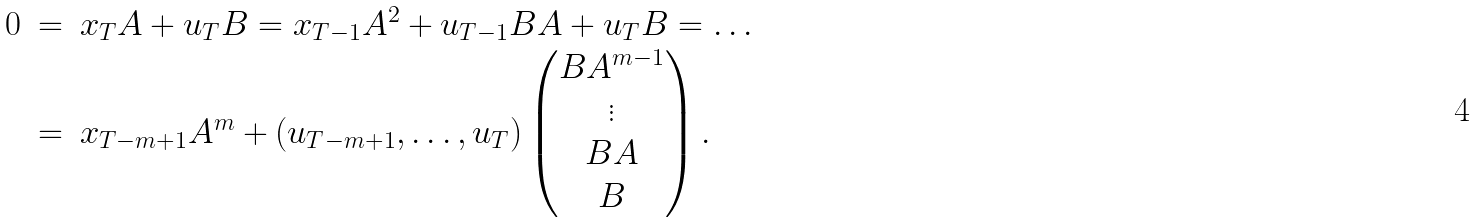<formula> <loc_0><loc_0><loc_500><loc_500>\begin{array} { r c l } 0 & = & x _ { T } A + u _ { T } B = x _ { T - 1 } A ^ { 2 } + u _ { T - 1 } B A + u _ { T } B = \dots \\ & = & x _ { T - m + 1 } A ^ { m } + ( u _ { T - m + 1 } , \dots , u _ { T } ) \begin{pmatrix} B A ^ { m - 1 } \\ \vdots \\ B A \\ B \end{pmatrix} . \end{array}</formula> 